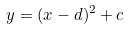Convert formula to latex. <formula><loc_0><loc_0><loc_500><loc_500>y = ( x - d ) ^ { 2 } + c</formula> 